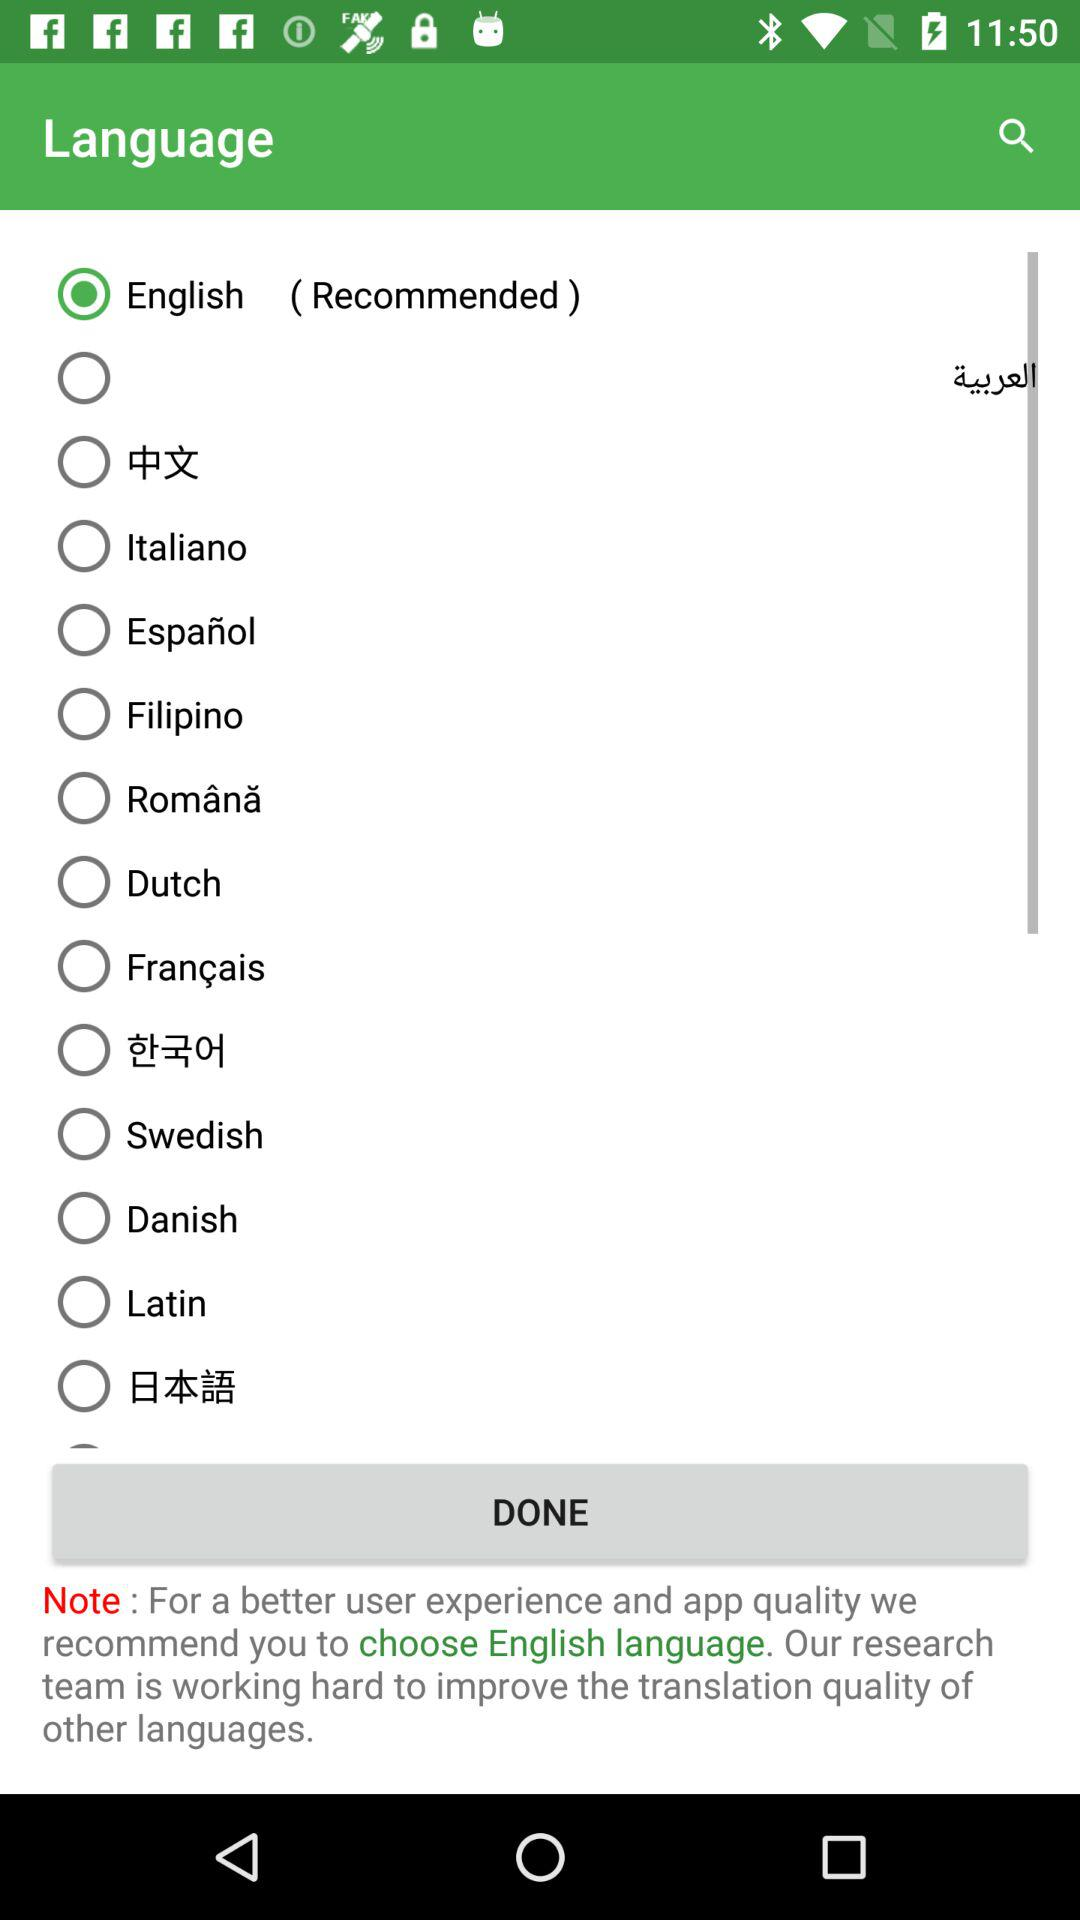Which radio button is selected? The selected radio button is "English ( Recommended )". 